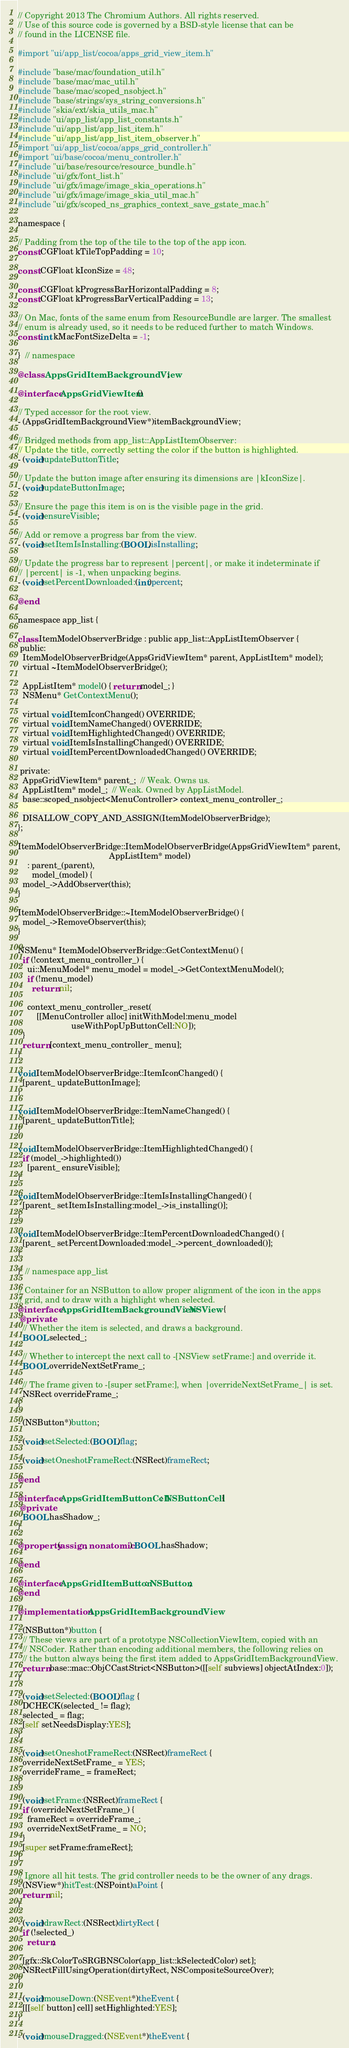<code> <loc_0><loc_0><loc_500><loc_500><_ObjectiveC_>// Copyright 2013 The Chromium Authors. All rights reserved.
// Use of this source code is governed by a BSD-style license that can be
// found in the LICENSE file.

#import "ui/app_list/cocoa/apps_grid_view_item.h"

#include "base/mac/foundation_util.h"
#include "base/mac/mac_util.h"
#include "base/mac/scoped_nsobject.h"
#include "base/strings/sys_string_conversions.h"
#include "skia/ext/skia_utils_mac.h"
#include "ui/app_list/app_list_constants.h"
#include "ui/app_list/app_list_item.h"
#include "ui/app_list/app_list_item_observer.h"
#import "ui/app_list/cocoa/apps_grid_controller.h"
#import "ui/base/cocoa/menu_controller.h"
#include "ui/base/resource/resource_bundle.h"
#include "ui/gfx/font_list.h"
#include "ui/gfx/image/image_skia_operations.h"
#include "ui/gfx/image/image_skia_util_mac.h"
#include "ui/gfx/scoped_ns_graphics_context_save_gstate_mac.h"

namespace {

// Padding from the top of the tile to the top of the app icon.
const CGFloat kTileTopPadding = 10;

const CGFloat kIconSize = 48;

const CGFloat kProgressBarHorizontalPadding = 8;
const CGFloat kProgressBarVerticalPadding = 13;

// On Mac, fonts of the same enum from ResourceBundle are larger. The smallest
// enum is already used, so it needs to be reduced further to match Windows.
const int kMacFontSizeDelta = -1;

}  // namespace

@class AppsGridItemBackgroundView;

@interface AppsGridViewItem ()

// Typed accessor for the root view.
- (AppsGridItemBackgroundView*)itemBackgroundView;

// Bridged methods from app_list::AppListItemObserver:
// Update the title, correctly setting the color if the button is highlighted.
- (void)updateButtonTitle;

// Update the button image after ensuring its dimensions are |kIconSize|.
- (void)updateButtonImage;

// Ensure the page this item is on is the visible page in the grid.
- (void)ensureVisible;

// Add or remove a progress bar from the view.
- (void)setItemIsInstalling:(BOOL)isInstalling;

// Update the progress bar to represent |percent|, or make it indeterminate if
// |percent| is -1, when unpacking begins.
- (void)setPercentDownloaded:(int)percent;

@end

namespace app_list {

class ItemModelObserverBridge : public app_list::AppListItemObserver {
 public:
  ItemModelObserverBridge(AppsGridViewItem* parent, AppListItem* model);
  virtual ~ItemModelObserverBridge();

  AppListItem* model() { return model_; }
  NSMenu* GetContextMenu();

  virtual void ItemIconChanged() OVERRIDE;
  virtual void ItemNameChanged() OVERRIDE;
  virtual void ItemHighlightedChanged() OVERRIDE;
  virtual void ItemIsInstallingChanged() OVERRIDE;
  virtual void ItemPercentDownloadedChanged() OVERRIDE;

 private:
  AppsGridViewItem* parent_;  // Weak. Owns us.
  AppListItem* model_;  // Weak. Owned by AppListModel.
  base::scoped_nsobject<MenuController> context_menu_controller_;

  DISALLOW_COPY_AND_ASSIGN(ItemModelObserverBridge);
};

ItemModelObserverBridge::ItemModelObserverBridge(AppsGridViewItem* parent,
                                       AppListItem* model)
    : parent_(parent),
      model_(model) {
  model_->AddObserver(this);
}

ItemModelObserverBridge::~ItemModelObserverBridge() {
  model_->RemoveObserver(this);
}

NSMenu* ItemModelObserverBridge::GetContextMenu() {
  if (!context_menu_controller_) {
    ui::MenuModel* menu_model = model_->GetContextMenuModel();
    if (!menu_model)
      return nil;

    context_menu_controller_.reset(
        [[MenuController alloc] initWithModel:menu_model
                       useWithPopUpButtonCell:NO]);
  }
  return [context_menu_controller_ menu];
}

void ItemModelObserverBridge::ItemIconChanged() {
  [parent_ updateButtonImage];
}

void ItemModelObserverBridge::ItemNameChanged() {
  [parent_ updateButtonTitle];
}

void ItemModelObserverBridge::ItemHighlightedChanged() {
  if (model_->highlighted())
    [parent_ ensureVisible];
}

void ItemModelObserverBridge::ItemIsInstallingChanged() {
  [parent_ setItemIsInstalling:model_->is_installing()];
}

void ItemModelObserverBridge::ItemPercentDownloadedChanged() {
  [parent_ setPercentDownloaded:model_->percent_downloaded()];
}

}  // namespace app_list

// Container for an NSButton to allow proper alignment of the icon in the apps
// grid, and to draw with a highlight when selected.
@interface AppsGridItemBackgroundView : NSView {
 @private
  // Whether the item is selected, and draws a background.
  BOOL selected_;

  // Whether to intercept the next call to -[NSView setFrame:] and override it.
  BOOL overrideNextSetFrame_;

  // The frame given to -[super setFrame:], when |overrideNextSetFrame_| is set.
  NSRect overrideFrame_;
}

- (NSButton*)button;

- (void)setSelected:(BOOL)flag;

- (void)setOneshotFrameRect:(NSRect)frameRect;

@end

@interface AppsGridItemButtonCell : NSButtonCell {
 @private
  BOOL hasShadow_;
}

@property(assign, nonatomic) BOOL hasShadow;

@end

@interface AppsGridItemButton : NSButton;
@end

@implementation AppsGridItemBackgroundView

- (NSButton*)button {
  // These views are part of a prototype NSCollectionViewItem, copied with an
  // NSCoder. Rather than encoding additional members, the following relies on
  // the button always being the first item added to AppsGridItemBackgroundView.
  return base::mac::ObjCCastStrict<NSButton>([[self subviews] objectAtIndex:0]);
}

- (void)setSelected:(BOOL)flag {
  DCHECK(selected_ != flag);
  selected_ = flag;
  [self setNeedsDisplay:YES];
}

- (void)setOneshotFrameRect:(NSRect)frameRect {
  overrideNextSetFrame_ = YES;
  overrideFrame_ = frameRect;
}

- (void)setFrame:(NSRect)frameRect {
  if (overrideNextSetFrame_) {
    frameRect = overrideFrame_;
    overrideNextSetFrame_ = NO;
  }
  [super setFrame:frameRect];
}

// Ignore all hit tests. The grid controller needs to be the owner of any drags.
- (NSView*)hitTest:(NSPoint)aPoint {
  return nil;
}

- (void)drawRect:(NSRect)dirtyRect {
  if (!selected_)
    return;

  [gfx::SkColorToSRGBNSColor(app_list::kSelectedColor) set];
  NSRectFillUsingOperation(dirtyRect, NSCompositeSourceOver);
}

- (void)mouseDown:(NSEvent*)theEvent {
  [[[self button] cell] setHighlighted:YES];
}

- (void)mouseDragged:(NSEvent*)theEvent {</code> 